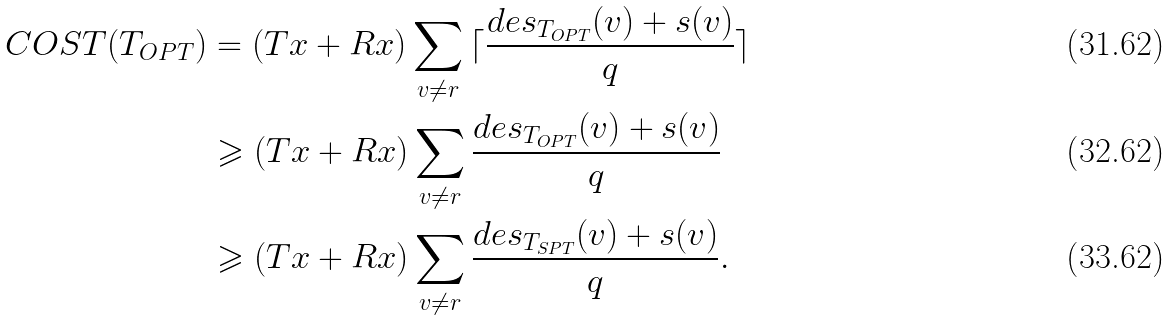<formula> <loc_0><loc_0><loc_500><loc_500>C O S T ( T _ { O P T } ) & = ( T x + R x ) \sum _ { v \neq r } { \lceil \frac { d e s _ { T _ { O P T } } ( v ) + s ( v ) } { q } \rceil } \\ & \geqslant ( T x + R x ) \sum _ { v \neq r } { \frac { d e s _ { T _ { O P T } } ( v ) + s ( v ) } { q } } \\ & \geqslant ( T x + R x ) \sum _ { v \neq r } { \frac { d e s _ { T _ { S P T } } ( v ) + s ( v ) } { q } } .</formula> 